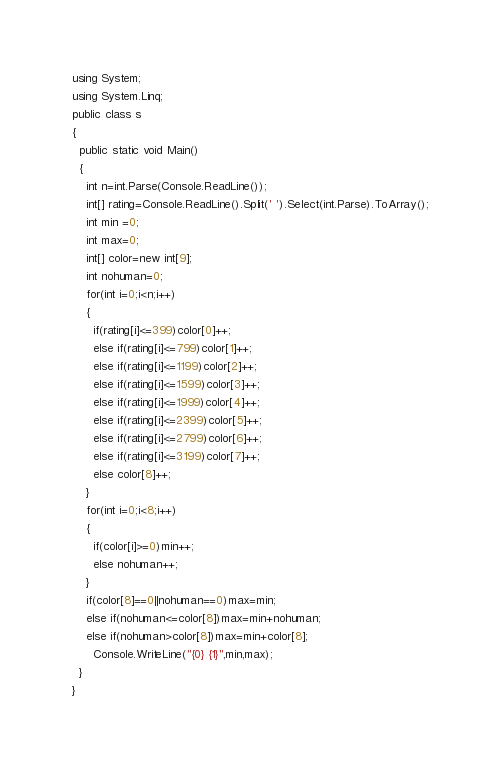<code> <loc_0><loc_0><loc_500><loc_500><_C#_>using System;
using System.Linq;
public class s
{
  public static void Main()
  {
    int n=int.Parse(Console.ReadLine());
    int[] rating=Console.ReadLine().Split(' ').Select(int.Parse).ToArray();
    int min =0;
    int max=0;
    int[] color=new int[9];
    int nohuman=0;
    for(int i=0;i<n;i++)
    {
      if(rating[i]<=399)color[0]++;
      else if(rating[i]<=799)color[1]++;
      else if(rating[i]<=1199)color[2]++;
      else if(rating[i]<=1599)color[3]++;
      else if(rating[i]<=1999)color[4]++;
      else if(rating[i]<=2399)color[5]++;
      else if(rating[i]<=2799)color[6]++;
      else if(rating[i]<=3199)color[7]++;
      else color[8]++;
    }
    for(int i=0;i<8;i++)
    {
      if(color[i]>=0)min++;
      else nohuman++;
    }
    if(color[8]==0||nohuman==0)max=min;
    else if(nohuman<=color[8])max=min+nohuman;
    else if(nohuman>color[8])max=min+color[8];
      Console.WriteLine("{0} {1}",min,max);
  }
}
</code> 